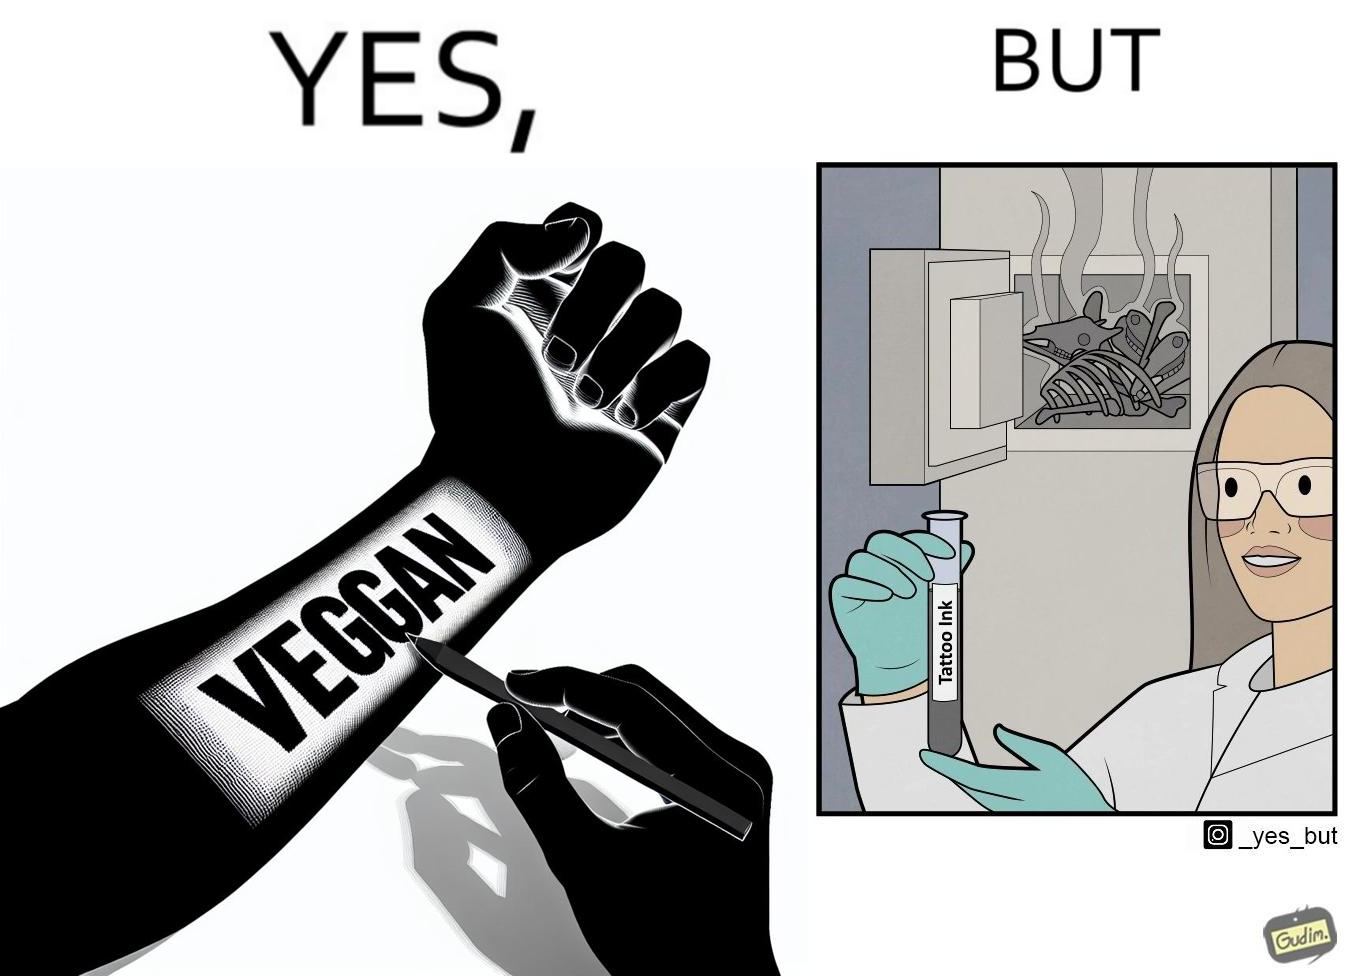Describe the contrast between the left and right parts of this image. In the left part of the image: Image of a person's tattoo that says 'vegan' In the right part of the image: Image of a scientist making tattoo ink using animal bones. 